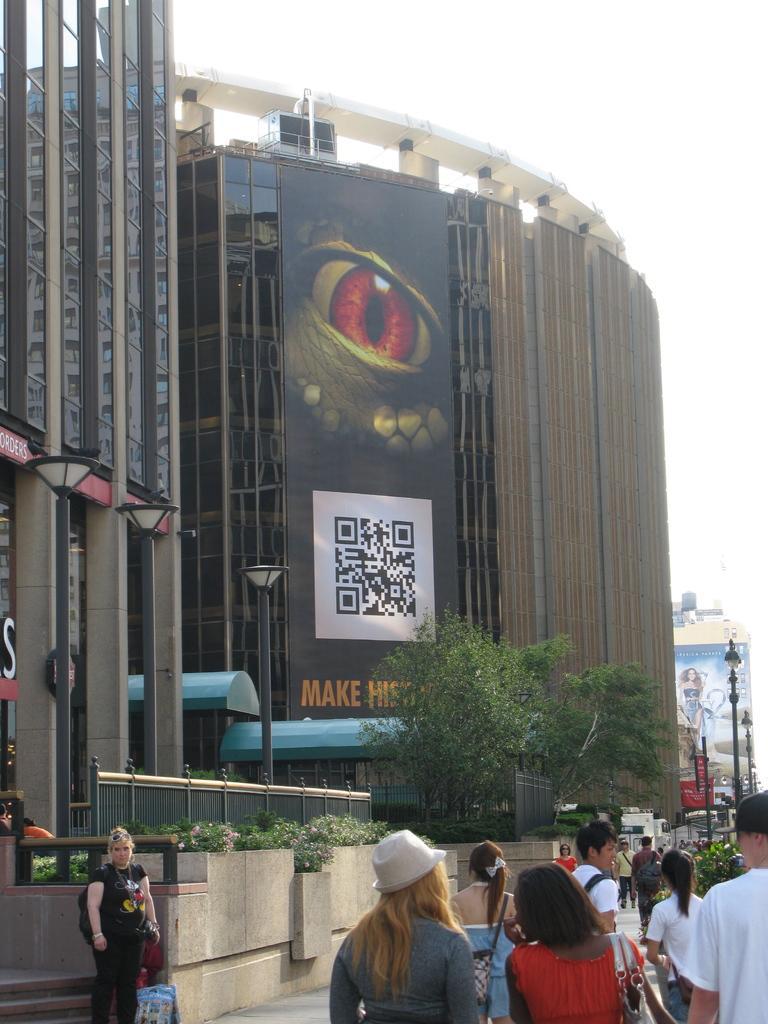In one or two sentences, can you explain what this image depicts? In this picture we can see some people are walking and some people are standing. On the right side of the people there are poles with lights and on the left side of the people there are plants, trees and buildings. Behind the buildings there is the sky and it looks like a hoarding. 